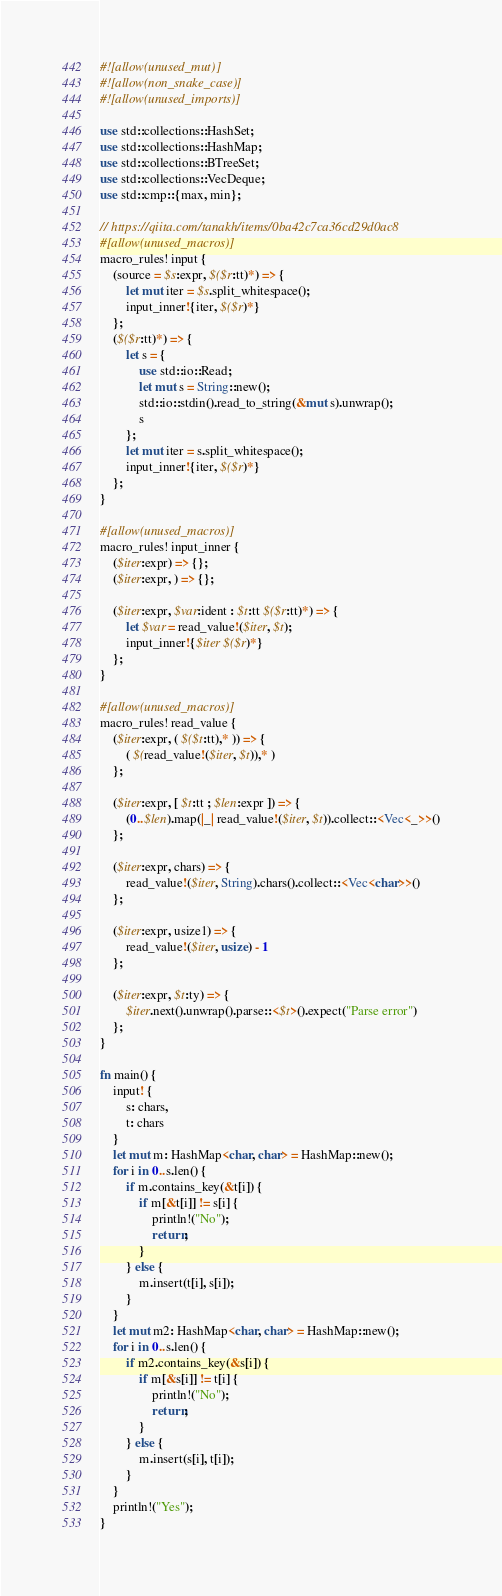Convert code to text. <code><loc_0><loc_0><loc_500><loc_500><_Rust_>#![allow(unused_mut)]
#![allow(non_snake_case)]
#![allow(unused_imports)]

use std::collections::HashSet;
use std::collections::HashMap;
use std::collections::BTreeSet;
use std::collections::VecDeque;
use std::cmp::{max, min};

// https://qiita.com/tanakh/items/0ba42c7ca36cd29d0ac8
#[allow(unused_macros)]
macro_rules! input {
    (source = $s:expr, $($r:tt)*) => {
        let mut iter = $s.split_whitespace();
        input_inner!{iter, $($r)*}
    };
    ($($r:tt)*) => {
        let s = {
            use std::io::Read;
            let mut s = String::new();
            std::io::stdin().read_to_string(&mut s).unwrap();
            s
        };
        let mut iter = s.split_whitespace();
        input_inner!{iter, $($r)*}
    };
}

#[allow(unused_macros)]
macro_rules! input_inner {
    ($iter:expr) => {};
    ($iter:expr, ) => {};

    ($iter:expr, $var:ident : $t:tt $($r:tt)*) => {
        let $var = read_value!($iter, $t);
        input_inner!{$iter $($r)*}
    };
}

#[allow(unused_macros)]
macro_rules! read_value {
    ($iter:expr, ( $($t:tt),* )) => {
        ( $(read_value!($iter, $t)),* )
    };

    ($iter:expr, [ $t:tt ; $len:expr ]) => {
        (0..$len).map(|_| read_value!($iter, $t)).collect::<Vec<_>>()
    };

    ($iter:expr, chars) => {
        read_value!($iter, String).chars().collect::<Vec<char>>()
    };

    ($iter:expr, usize1) => {
        read_value!($iter, usize) - 1
    };

    ($iter:expr, $t:ty) => {
        $iter.next().unwrap().parse::<$t>().expect("Parse error")
    };
}

fn main() {
    input! {
        s: chars,
        t: chars
    }
    let mut m: HashMap<char, char> = HashMap::new();
    for i in 0..s.len() {
        if m.contains_key(&t[i]) {
            if m[&t[i]] != s[i] {
                println!("No");
                return;
            }
        } else {
            m.insert(t[i], s[i]);
        }
    }
    let mut m2: HashMap<char, char> = HashMap::new();
    for i in 0..s.len() {
        if m2.contains_key(&s[i]) {
            if m[&s[i]] != t[i] {
                println!("No");
                return;
            }
        } else {
            m.insert(s[i], t[i]);
        }
    }
    println!("Yes");
}</code> 